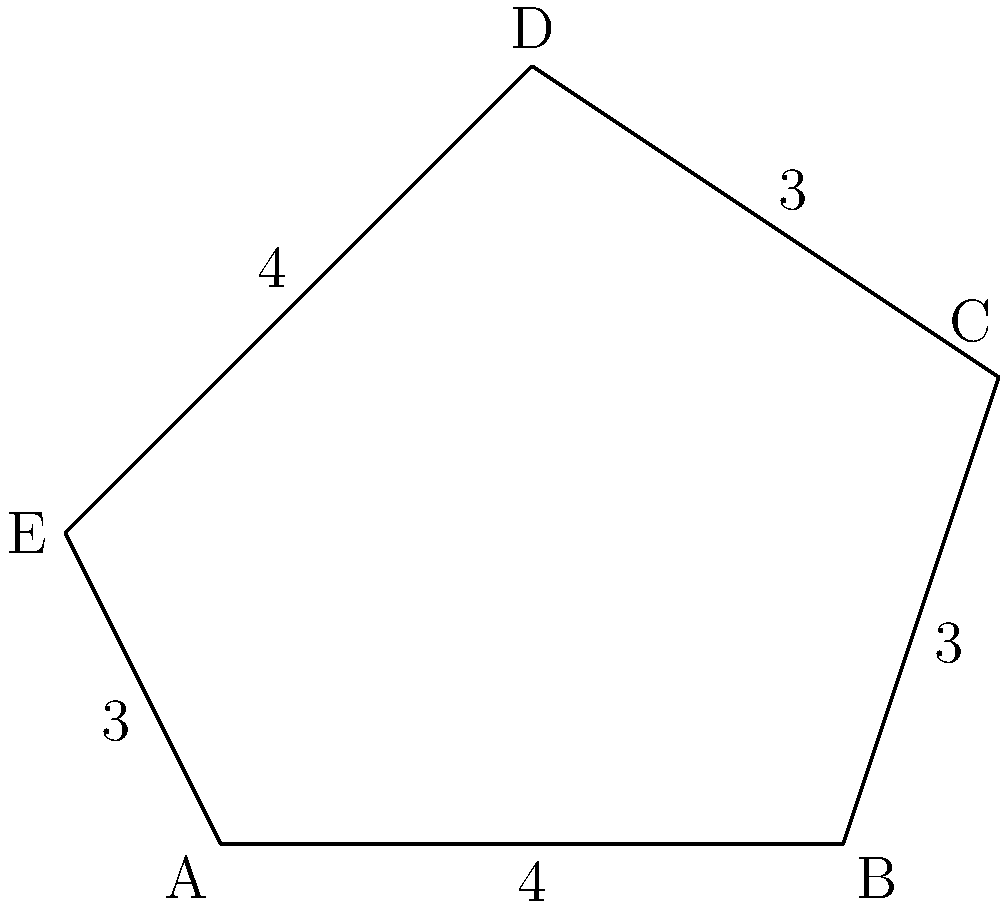As a public policy expert advising on urban development, you're reviewing plans for a new construction zone. The site has a pentagonal shape, as shown in the diagram. If the fencing cost is $25 per meter, what would be the total cost to fence the entire perimeter of the construction zone? To solve this problem, we need to follow these steps:

1. Calculate the perimeter of the pentagonal construction zone:
   - The pentagon has 5 sides with lengths: 4m, 3m, 3m, 4m, and 3m
   - Perimeter = sum of all sides
   - $Perimeter = 4 + 3 + 3 + 4 + 3 = 17$ meters

2. Calculate the cost of fencing:
   - Cost per meter = $25
   - Total cost = Perimeter × Cost per meter
   - Total cost = $17 \times \$25 = \$425$

Therefore, the total cost to fence the entire perimeter of the construction zone would be $425.
Answer: $425 